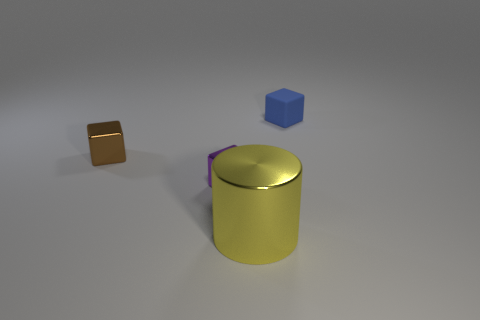How many other shiny objects have the same size as the brown metal thing?
Give a very brief answer. 1. What number of shiny objects are left of the metallic cube in front of the brown shiny cube?
Provide a succinct answer. 1. Does the small object in front of the brown shiny object have the same material as the yellow cylinder?
Your response must be concise. Yes. Is the material of the tiny cube to the left of the purple shiny thing the same as the small thing in front of the tiny brown object?
Offer a terse response. Yes. Is the number of small cubes that are to the left of the large thing greater than the number of large brown metallic spheres?
Offer a very short reply. Yes. What color is the tiny shiny block that is to the left of the shiny block that is in front of the brown object?
Your answer should be compact. Brown. The blue thing that is the same size as the purple metallic thing is what shape?
Make the answer very short. Cube. Are there the same number of big yellow metal objects that are behind the tiny blue cube and small purple shiny objects?
Provide a short and direct response. No. What is the material of the tiny thing in front of the shiny block that is left of the shiny block in front of the tiny brown block?
Keep it short and to the point. Metal. What is the shape of the other tiny thing that is the same material as the small brown thing?
Make the answer very short. Cube. 